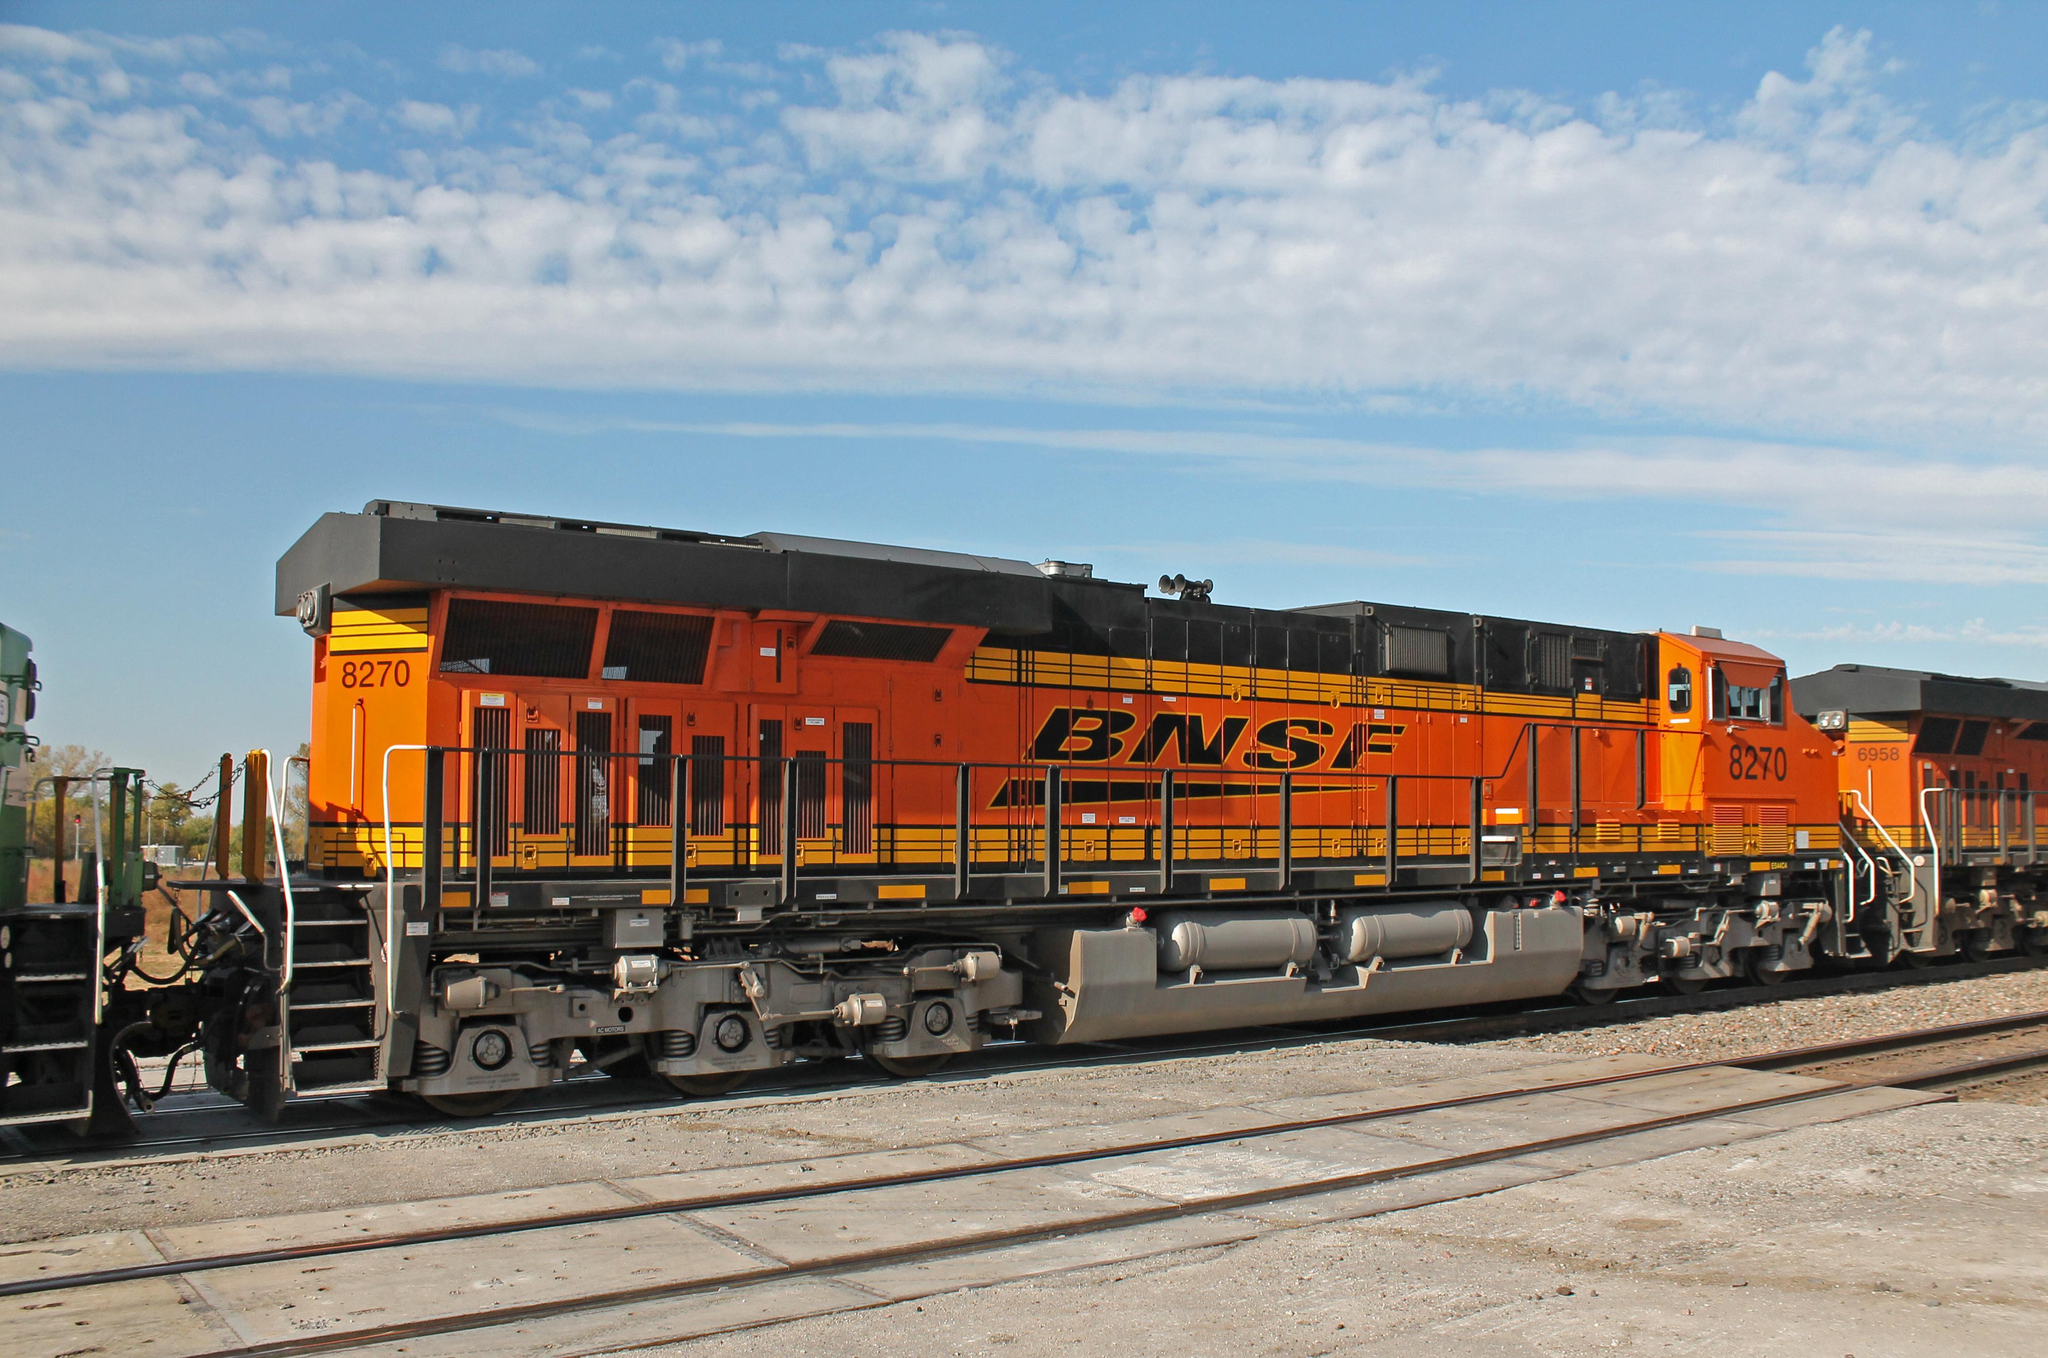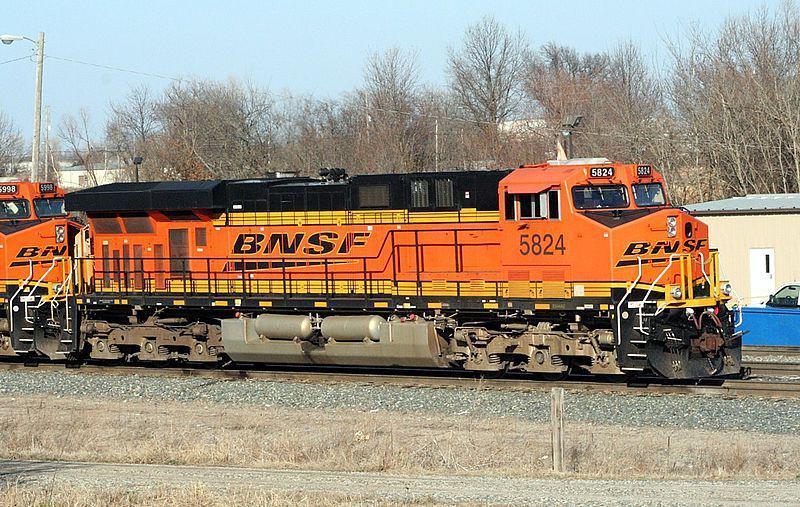The first image is the image on the left, the second image is the image on the right. For the images shown, is this caption "The train in the right image is facing left." true? Answer yes or no. No. 